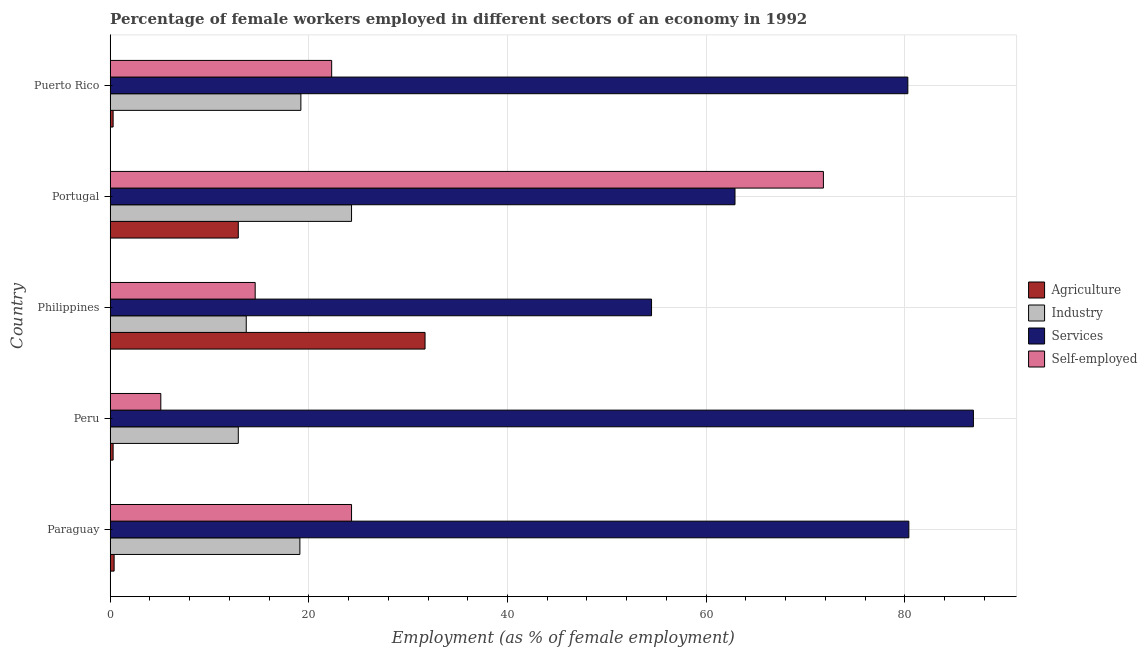How many groups of bars are there?
Ensure brevity in your answer.  5. How many bars are there on the 1st tick from the top?
Offer a very short reply. 4. What is the label of the 2nd group of bars from the top?
Keep it short and to the point. Portugal. In how many cases, is the number of bars for a given country not equal to the number of legend labels?
Offer a very short reply. 0. What is the percentage of self employed female workers in Portugal?
Ensure brevity in your answer.  71.8. Across all countries, what is the maximum percentage of female workers in industry?
Your answer should be compact. 24.3. Across all countries, what is the minimum percentage of female workers in services?
Ensure brevity in your answer.  54.5. In which country was the percentage of female workers in agriculture maximum?
Give a very brief answer. Philippines. What is the total percentage of female workers in industry in the graph?
Offer a terse response. 89.2. What is the difference between the percentage of self employed female workers in Peru and that in Portugal?
Keep it short and to the point. -66.7. What is the difference between the percentage of self employed female workers in Peru and the percentage of female workers in industry in Portugal?
Your response must be concise. -19.2. What is the average percentage of self employed female workers per country?
Your answer should be compact. 27.62. What is the difference between the percentage of female workers in agriculture and percentage of female workers in industry in Puerto Rico?
Your answer should be compact. -18.9. In how many countries, is the percentage of female workers in industry greater than 84 %?
Give a very brief answer. 0. What is the ratio of the percentage of self employed female workers in Philippines to that in Portugal?
Give a very brief answer. 0.2. What is the difference between the highest and the second highest percentage of female workers in agriculture?
Ensure brevity in your answer.  18.8. What is the difference between the highest and the lowest percentage of female workers in services?
Provide a succinct answer. 32.4. In how many countries, is the percentage of self employed female workers greater than the average percentage of self employed female workers taken over all countries?
Offer a very short reply. 1. Is the sum of the percentage of female workers in services in Peru and Puerto Rico greater than the maximum percentage of female workers in agriculture across all countries?
Offer a terse response. Yes. Is it the case that in every country, the sum of the percentage of female workers in services and percentage of female workers in industry is greater than the sum of percentage of female workers in agriculture and percentage of self employed female workers?
Your response must be concise. No. What does the 3rd bar from the top in Peru represents?
Offer a terse response. Industry. What does the 2nd bar from the bottom in Paraguay represents?
Give a very brief answer. Industry. How many countries are there in the graph?
Ensure brevity in your answer.  5. Does the graph contain grids?
Provide a succinct answer. Yes. Where does the legend appear in the graph?
Your answer should be very brief. Center right. How many legend labels are there?
Your response must be concise. 4. How are the legend labels stacked?
Make the answer very short. Vertical. What is the title of the graph?
Ensure brevity in your answer.  Percentage of female workers employed in different sectors of an economy in 1992. What is the label or title of the X-axis?
Offer a terse response. Employment (as % of female employment). What is the Employment (as % of female employment) in Agriculture in Paraguay?
Your answer should be compact. 0.4. What is the Employment (as % of female employment) of Industry in Paraguay?
Provide a short and direct response. 19.1. What is the Employment (as % of female employment) of Services in Paraguay?
Your answer should be very brief. 80.4. What is the Employment (as % of female employment) in Self-employed in Paraguay?
Your answer should be compact. 24.3. What is the Employment (as % of female employment) of Agriculture in Peru?
Ensure brevity in your answer.  0.3. What is the Employment (as % of female employment) of Industry in Peru?
Ensure brevity in your answer.  12.9. What is the Employment (as % of female employment) in Services in Peru?
Your answer should be compact. 86.9. What is the Employment (as % of female employment) in Self-employed in Peru?
Your answer should be compact. 5.1. What is the Employment (as % of female employment) in Agriculture in Philippines?
Offer a terse response. 31.7. What is the Employment (as % of female employment) of Industry in Philippines?
Keep it short and to the point. 13.7. What is the Employment (as % of female employment) in Services in Philippines?
Provide a short and direct response. 54.5. What is the Employment (as % of female employment) of Self-employed in Philippines?
Provide a succinct answer. 14.6. What is the Employment (as % of female employment) of Agriculture in Portugal?
Offer a very short reply. 12.9. What is the Employment (as % of female employment) in Industry in Portugal?
Your answer should be compact. 24.3. What is the Employment (as % of female employment) of Services in Portugal?
Your answer should be compact. 62.9. What is the Employment (as % of female employment) in Self-employed in Portugal?
Your answer should be very brief. 71.8. What is the Employment (as % of female employment) of Agriculture in Puerto Rico?
Your answer should be compact. 0.3. What is the Employment (as % of female employment) of Industry in Puerto Rico?
Your answer should be very brief. 19.2. What is the Employment (as % of female employment) of Services in Puerto Rico?
Provide a succinct answer. 80.3. What is the Employment (as % of female employment) of Self-employed in Puerto Rico?
Your answer should be very brief. 22.3. Across all countries, what is the maximum Employment (as % of female employment) of Agriculture?
Provide a succinct answer. 31.7. Across all countries, what is the maximum Employment (as % of female employment) of Industry?
Provide a short and direct response. 24.3. Across all countries, what is the maximum Employment (as % of female employment) in Services?
Your answer should be very brief. 86.9. Across all countries, what is the maximum Employment (as % of female employment) in Self-employed?
Provide a succinct answer. 71.8. Across all countries, what is the minimum Employment (as % of female employment) of Agriculture?
Make the answer very short. 0.3. Across all countries, what is the minimum Employment (as % of female employment) in Industry?
Ensure brevity in your answer.  12.9. Across all countries, what is the minimum Employment (as % of female employment) in Services?
Your response must be concise. 54.5. Across all countries, what is the minimum Employment (as % of female employment) in Self-employed?
Ensure brevity in your answer.  5.1. What is the total Employment (as % of female employment) of Agriculture in the graph?
Provide a succinct answer. 45.6. What is the total Employment (as % of female employment) of Industry in the graph?
Ensure brevity in your answer.  89.2. What is the total Employment (as % of female employment) in Services in the graph?
Ensure brevity in your answer.  365. What is the total Employment (as % of female employment) of Self-employed in the graph?
Give a very brief answer. 138.1. What is the difference between the Employment (as % of female employment) in Agriculture in Paraguay and that in Peru?
Make the answer very short. 0.1. What is the difference between the Employment (as % of female employment) of Industry in Paraguay and that in Peru?
Offer a very short reply. 6.2. What is the difference between the Employment (as % of female employment) of Agriculture in Paraguay and that in Philippines?
Offer a terse response. -31.3. What is the difference between the Employment (as % of female employment) of Industry in Paraguay and that in Philippines?
Your answer should be very brief. 5.4. What is the difference between the Employment (as % of female employment) in Services in Paraguay and that in Philippines?
Provide a succinct answer. 25.9. What is the difference between the Employment (as % of female employment) in Self-employed in Paraguay and that in Philippines?
Keep it short and to the point. 9.7. What is the difference between the Employment (as % of female employment) of Services in Paraguay and that in Portugal?
Keep it short and to the point. 17.5. What is the difference between the Employment (as % of female employment) in Self-employed in Paraguay and that in Portugal?
Provide a short and direct response. -47.5. What is the difference between the Employment (as % of female employment) in Self-employed in Paraguay and that in Puerto Rico?
Keep it short and to the point. 2. What is the difference between the Employment (as % of female employment) of Agriculture in Peru and that in Philippines?
Make the answer very short. -31.4. What is the difference between the Employment (as % of female employment) in Services in Peru and that in Philippines?
Offer a terse response. 32.4. What is the difference between the Employment (as % of female employment) in Agriculture in Peru and that in Portugal?
Your answer should be compact. -12.6. What is the difference between the Employment (as % of female employment) of Industry in Peru and that in Portugal?
Offer a very short reply. -11.4. What is the difference between the Employment (as % of female employment) in Self-employed in Peru and that in Portugal?
Keep it short and to the point. -66.7. What is the difference between the Employment (as % of female employment) in Industry in Peru and that in Puerto Rico?
Provide a short and direct response. -6.3. What is the difference between the Employment (as % of female employment) of Services in Peru and that in Puerto Rico?
Offer a terse response. 6.6. What is the difference between the Employment (as % of female employment) of Self-employed in Peru and that in Puerto Rico?
Ensure brevity in your answer.  -17.2. What is the difference between the Employment (as % of female employment) of Agriculture in Philippines and that in Portugal?
Your answer should be compact. 18.8. What is the difference between the Employment (as % of female employment) in Services in Philippines and that in Portugal?
Make the answer very short. -8.4. What is the difference between the Employment (as % of female employment) of Self-employed in Philippines and that in Portugal?
Your response must be concise. -57.2. What is the difference between the Employment (as % of female employment) of Agriculture in Philippines and that in Puerto Rico?
Provide a succinct answer. 31.4. What is the difference between the Employment (as % of female employment) of Services in Philippines and that in Puerto Rico?
Make the answer very short. -25.8. What is the difference between the Employment (as % of female employment) in Self-employed in Philippines and that in Puerto Rico?
Provide a succinct answer. -7.7. What is the difference between the Employment (as % of female employment) in Agriculture in Portugal and that in Puerto Rico?
Provide a succinct answer. 12.6. What is the difference between the Employment (as % of female employment) of Services in Portugal and that in Puerto Rico?
Make the answer very short. -17.4. What is the difference between the Employment (as % of female employment) in Self-employed in Portugal and that in Puerto Rico?
Offer a terse response. 49.5. What is the difference between the Employment (as % of female employment) of Agriculture in Paraguay and the Employment (as % of female employment) of Services in Peru?
Your answer should be compact. -86.5. What is the difference between the Employment (as % of female employment) of Agriculture in Paraguay and the Employment (as % of female employment) of Self-employed in Peru?
Offer a terse response. -4.7. What is the difference between the Employment (as % of female employment) of Industry in Paraguay and the Employment (as % of female employment) of Services in Peru?
Provide a short and direct response. -67.8. What is the difference between the Employment (as % of female employment) in Industry in Paraguay and the Employment (as % of female employment) in Self-employed in Peru?
Offer a very short reply. 14. What is the difference between the Employment (as % of female employment) in Services in Paraguay and the Employment (as % of female employment) in Self-employed in Peru?
Offer a terse response. 75.3. What is the difference between the Employment (as % of female employment) in Agriculture in Paraguay and the Employment (as % of female employment) in Services in Philippines?
Offer a terse response. -54.1. What is the difference between the Employment (as % of female employment) in Agriculture in Paraguay and the Employment (as % of female employment) in Self-employed in Philippines?
Keep it short and to the point. -14.2. What is the difference between the Employment (as % of female employment) in Industry in Paraguay and the Employment (as % of female employment) in Services in Philippines?
Give a very brief answer. -35.4. What is the difference between the Employment (as % of female employment) of Industry in Paraguay and the Employment (as % of female employment) of Self-employed in Philippines?
Provide a short and direct response. 4.5. What is the difference between the Employment (as % of female employment) in Services in Paraguay and the Employment (as % of female employment) in Self-employed in Philippines?
Offer a terse response. 65.8. What is the difference between the Employment (as % of female employment) of Agriculture in Paraguay and the Employment (as % of female employment) of Industry in Portugal?
Your response must be concise. -23.9. What is the difference between the Employment (as % of female employment) of Agriculture in Paraguay and the Employment (as % of female employment) of Services in Portugal?
Ensure brevity in your answer.  -62.5. What is the difference between the Employment (as % of female employment) of Agriculture in Paraguay and the Employment (as % of female employment) of Self-employed in Portugal?
Provide a succinct answer. -71.4. What is the difference between the Employment (as % of female employment) of Industry in Paraguay and the Employment (as % of female employment) of Services in Portugal?
Make the answer very short. -43.8. What is the difference between the Employment (as % of female employment) in Industry in Paraguay and the Employment (as % of female employment) in Self-employed in Portugal?
Your answer should be compact. -52.7. What is the difference between the Employment (as % of female employment) of Services in Paraguay and the Employment (as % of female employment) of Self-employed in Portugal?
Offer a terse response. 8.6. What is the difference between the Employment (as % of female employment) of Agriculture in Paraguay and the Employment (as % of female employment) of Industry in Puerto Rico?
Offer a terse response. -18.8. What is the difference between the Employment (as % of female employment) of Agriculture in Paraguay and the Employment (as % of female employment) of Services in Puerto Rico?
Make the answer very short. -79.9. What is the difference between the Employment (as % of female employment) in Agriculture in Paraguay and the Employment (as % of female employment) in Self-employed in Puerto Rico?
Provide a succinct answer. -21.9. What is the difference between the Employment (as % of female employment) in Industry in Paraguay and the Employment (as % of female employment) in Services in Puerto Rico?
Ensure brevity in your answer.  -61.2. What is the difference between the Employment (as % of female employment) of Services in Paraguay and the Employment (as % of female employment) of Self-employed in Puerto Rico?
Give a very brief answer. 58.1. What is the difference between the Employment (as % of female employment) of Agriculture in Peru and the Employment (as % of female employment) of Services in Philippines?
Make the answer very short. -54.2. What is the difference between the Employment (as % of female employment) of Agriculture in Peru and the Employment (as % of female employment) of Self-employed in Philippines?
Your answer should be compact. -14.3. What is the difference between the Employment (as % of female employment) in Industry in Peru and the Employment (as % of female employment) in Services in Philippines?
Provide a short and direct response. -41.6. What is the difference between the Employment (as % of female employment) of Industry in Peru and the Employment (as % of female employment) of Self-employed in Philippines?
Offer a very short reply. -1.7. What is the difference between the Employment (as % of female employment) of Services in Peru and the Employment (as % of female employment) of Self-employed in Philippines?
Offer a very short reply. 72.3. What is the difference between the Employment (as % of female employment) of Agriculture in Peru and the Employment (as % of female employment) of Services in Portugal?
Provide a short and direct response. -62.6. What is the difference between the Employment (as % of female employment) of Agriculture in Peru and the Employment (as % of female employment) of Self-employed in Portugal?
Give a very brief answer. -71.5. What is the difference between the Employment (as % of female employment) in Industry in Peru and the Employment (as % of female employment) in Self-employed in Portugal?
Make the answer very short. -58.9. What is the difference between the Employment (as % of female employment) of Services in Peru and the Employment (as % of female employment) of Self-employed in Portugal?
Keep it short and to the point. 15.1. What is the difference between the Employment (as % of female employment) of Agriculture in Peru and the Employment (as % of female employment) of Industry in Puerto Rico?
Your answer should be compact. -18.9. What is the difference between the Employment (as % of female employment) in Agriculture in Peru and the Employment (as % of female employment) in Services in Puerto Rico?
Give a very brief answer. -80. What is the difference between the Employment (as % of female employment) of Agriculture in Peru and the Employment (as % of female employment) of Self-employed in Puerto Rico?
Offer a very short reply. -22. What is the difference between the Employment (as % of female employment) of Industry in Peru and the Employment (as % of female employment) of Services in Puerto Rico?
Your response must be concise. -67.4. What is the difference between the Employment (as % of female employment) of Industry in Peru and the Employment (as % of female employment) of Self-employed in Puerto Rico?
Offer a very short reply. -9.4. What is the difference between the Employment (as % of female employment) in Services in Peru and the Employment (as % of female employment) in Self-employed in Puerto Rico?
Your answer should be compact. 64.6. What is the difference between the Employment (as % of female employment) in Agriculture in Philippines and the Employment (as % of female employment) in Services in Portugal?
Your response must be concise. -31.2. What is the difference between the Employment (as % of female employment) in Agriculture in Philippines and the Employment (as % of female employment) in Self-employed in Portugal?
Your answer should be compact. -40.1. What is the difference between the Employment (as % of female employment) of Industry in Philippines and the Employment (as % of female employment) of Services in Portugal?
Offer a very short reply. -49.2. What is the difference between the Employment (as % of female employment) in Industry in Philippines and the Employment (as % of female employment) in Self-employed in Portugal?
Offer a terse response. -58.1. What is the difference between the Employment (as % of female employment) in Services in Philippines and the Employment (as % of female employment) in Self-employed in Portugal?
Keep it short and to the point. -17.3. What is the difference between the Employment (as % of female employment) of Agriculture in Philippines and the Employment (as % of female employment) of Industry in Puerto Rico?
Make the answer very short. 12.5. What is the difference between the Employment (as % of female employment) of Agriculture in Philippines and the Employment (as % of female employment) of Services in Puerto Rico?
Provide a short and direct response. -48.6. What is the difference between the Employment (as % of female employment) of Agriculture in Philippines and the Employment (as % of female employment) of Self-employed in Puerto Rico?
Your answer should be very brief. 9.4. What is the difference between the Employment (as % of female employment) in Industry in Philippines and the Employment (as % of female employment) in Services in Puerto Rico?
Offer a terse response. -66.6. What is the difference between the Employment (as % of female employment) in Industry in Philippines and the Employment (as % of female employment) in Self-employed in Puerto Rico?
Make the answer very short. -8.6. What is the difference between the Employment (as % of female employment) of Services in Philippines and the Employment (as % of female employment) of Self-employed in Puerto Rico?
Offer a terse response. 32.2. What is the difference between the Employment (as % of female employment) of Agriculture in Portugal and the Employment (as % of female employment) of Industry in Puerto Rico?
Provide a succinct answer. -6.3. What is the difference between the Employment (as % of female employment) of Agriculture in Portugal and the Employment (as % of female employment) of Services in Puerto Rico?
Provide a short and direct response. -67.4. What is the difference between the Employment (as % of female employment) in Industry in Portugal and the Employment (as % of female employment) in Services in Puerto Rico?
Your answer should be very brief. -56. What is the difference between the Employment (as % of female employment) in Industry in Portugal and the Employment (as % of female employment) in Self-employed in Puerto Rico?
Make the answer very short. 2. What is the difference between the Employment (as % of female employment) in Services in Portugal and the Employment (as % of female employment) in Self-employed in Puerto Rico?
Your response must be concise. 40.6. What is the average Employment (as % of female employment) in Agriculture per country?
Your response must be concise. 9.12. What is the average Employment (as % of female employment) of Industry per country?
Your answer should be very brief. 17.84. What is the average Employment (as % of female employment) in Self-employed per country?
Provide a short and direct response. 27.62. What is the difference between the Employment (as % of female employment) in Agriculture and Employment (as % of female employment) in Industry in Paraguay?
Ensure brevity in your answer.  -18.7. What is the difference between the Employment (as % of female employment) of Agriculture and Employment (as % of female employment) of Services in Paraguay?
Provide a short and direct response. -80. What is the difference between the Employment (as % of female employment) in Agriculture and Employment (as % of female employment) in Self-employed in Paraguay?
Offer a terse response. -23.9. What is the difference between the Employment (as % of female employment) in Industry and Employment (as % of female employment) in Services in Paraguay?
Offer a terse response. -61.3. What is the difference between the Employment (as % of female employment) of Industry and Employment (as % of female employment) of Self-employed in Paraguay?
Keep it short and to the point. -5.2. What is the difference between the Employment (as % of female employment) of Services and Employment (as % of female employment) of Self-employed in Paraguay?
Provide a short and direct response. 56.1. What is the difference between the Employment (as % of female employment) in Agriculture and Employment (as % of female employment) in Industry in Peru?
Provide a short and direct response. -12.6. What is the difference between the Employment (as % of female employment) of Agriculture and Employment (as % of female employment) of Services in Peru?
Your answer should be very brief. -86.6. What is the difference between the Employment (as % of female employment) in Agriculture and Employment (as % of female employment) in Self-employed in Peru?
Your answer should be very brief. -4.8. What is the difference between the Employment (as % of female employment) in Industry and Employment (as % of female employment) in Services in Peru?
Provide a succinct answer. -74. What is the difference between the Employment (as % of female employment) of Industry and Employment (as % of female employment) of Self-employed in Peru?
Provide a short and direct response. 7.8. What is the difference between the Employment (as % of female employment) in Services and Employment (as % of female employment) in Self-employed in Peru?
Your response must be concise. 81.8. What is the difference between the Employment (as % of female employment) of Agriculture and Employment (as % of female employment) of Services in Philippines?
Offer a very short reply. -22.8. What is the difference between the Employment (as % of female employment) of Agriculture and Employment (as % of female employment) of Self-employed in Philippines?
Offer a very short reply. 17.1. What is the difference between the Employment (as % of female employment) in Industry and Employment (as % of female employment) in Services in Philippines?
Your answer should be very brief. -40.8. What is the difference between the Employment (as % of female employment) of Industry and Employment (as % of female employment) of Self-employed in Philippines?
Ensure brevity in your answer.  -0.9. What is the difference between the Employment (as % of female employment) of Services and Employment (as % of female employment) of Self-employed in Philippines?
Make the answer very short. 39.9. What is the difference between the Employment (as % of female employment) of Agriculture and Employment (as % of female employment) of Services in Portugal?
Offer a terse response. -50. What is the difference between the Employment (as % of female employment) of Agriculture and Employment (as % of female employment) of Self-employed in Portugal?
Your answer should be very brief. -58.9. What is the difference between the Employment (as % of female employment) of Industry and Employment (as % of female employment) of Services in Portugal?
Provide a succinct answer. -38.6. What is the difference between the Employment (as % of female employment) of Industry and Employment (as % of female employment) of Self-employed in Portugal?
Your answer should be very brief. -47.5. What is the difference between the Employment (as % of female employment) of Agriculture and Employment (as % of female employment) of Industry in Puerto Rico?
Your answer should be compact. -18.9. What is the difference between the Employment (as % of female employment) of Agriculture and Employment (as % of female employment) of Services in Puerto Rico?
Your answer should be very brief. -80. What is the difference between the Employment (as % of female employment) of Industry and Employment (as % of female employment) of Services in Puerto Rico?
Offer a terse response. -61.1. What is the difference between the Employment (as % of female employment) of Industry and Employment (as % of female employment) of Self-employed in Puerto Rico?
Provide a short and direct response. -3.1. What is the difference between the Employment (as % of female employment) of Services and Employment (as % of female employment) of Self-employed in Puerto Rico?
Provide a short and direct response. 58. What is the ratio of the Employment (as % of female employment) in Agriculture in Paraguay to that in Peru?
Your answer should be compact. 1.33. What is the ratio of the Employment (as % of female employment) of Industry in Paraguay to that in Peru?
Your answer should be compact. 1.48. What is the ratio of the Employment (as % of female employment) in Services in Paraguay to that in Peru?
Ensure brevity in your answer.  0.93. What is the ratio of the Employment (as % of female employment) of Self-employed in Paraguay to that in Peru?
Give a very brief answer. 4.76. What is the ratio of the Employment (as % of female employment) in Agriculture in Paraguay to that in Philippines?
Ensure brevity in your answer.  0.01. What is the ratio of the Employment (as % of female employment) in Industry in Paraguay to that in Philippines?
Keep it short and to the point. 1.39. What is the ratio of the Employment (as % of female employment) of Services in Paraguay to that in Philippines?
Your response must be concise. 1.48. What is the ratio of the Employment (as % of female employment) of Self-employed in Paraguay to that in Philippines?
Keep it short and to the point. 1.66. What is the ratio of the Employment (as % of female employment) of Agriculture in Paraguay to that in Portugal?
Give a very brief answer. 0.03. What is the ratio of the Employment (as % of female employment) of Industry in Paraguay to that in Portugal?
Provide a short and direct response. 0.79. What is the ratio of the Employment (as % of female employment) in Services in Paraguay to that in Portugal?
Your answer should be very brief. 1.28. What is the ratio of the Employment (as % of female employment) of Self-employed in Paraguay to that in Portugal?
Make the answer very short. 0.34. What is the ratio of the Employment (as % of female employment) of Self-employed in Paraguay to that in Puerto Rico?
Keep it short and to the point. 1.09. What is the ratio of the Employment (as % of female employment) of Agriculture in Peru to that in Philippines?
Ensure brevity in your answer.  0.01. What is the ratio of the Employment (as % of female employment) of Industry in Peru to that in Philippines?
Offer a very short reply. 0.94. What is the ratio of the Employment (as % of female employment) of Services in Peru to that in Philippines?
Give a very brief answer. 1.59. What is the ratio of the Employment (as % of female employment) in Self-employed in Peru to that in Philippines?
Your response must be concise. 0.35. What is the ratio of the Employment (as % of female employment) in Agriculture in Peru to that in Portugal?
Keep it short and to the point. 0.02. What is the ratio of the Employment (as % of female employment) of Industry in Peru to that in Portugal?
Keep it short and to the point. 0.53. What is the ratio of the Employment (as % of female employment) of Services in Peru to that in Portugal?
Provide a short and direct response. 1.38. What is the ratio of the Employment (as % of female employment) in Self-employed in Peru to that in Portugal?
Keep it short and to the point. 0.07. What is the ratio of the Employment (as % of female employment) of Industry in Peru to that in Puerto Rico?
Your answer should be very brief. 0.67. What is the ratio of the Employment (as % of female employment) of Services in Peru to that in Puerto Rico?
Offer a very short reply. 1.08. What is the ratio of the Employment (as % of female employment) of Self-employed in Peru to that in Puerto Rico?
Offer a terse response. 0.23. What is the ratio of the Employment (as % of female employment) of Agriculture in Philippines to that in Portugal?
Ensure brevity in your answer.  2.46. What is the ratio of the Employment (as % of female employment) in Industry in Philippines to that in Portugal?
Keep it short and to the point. 0.56. What is the ratio of the Employment (as % of female employment) of Services in Philippines to that in Portugal?
Keep it short and to the point. 0.87. What is the ratio of the Employment (as % of female employment) of Self-employed in Philippines to that in Portugal?
Offer a very short reply. 0.2. What is the ratio of the Employment (as % of female employment) in Agriculture in Philippines to that in Puerto Rico?
Make the answer very short. 105.67. What is the ratio of the Employment (as % of female employment) in Industry in Philippines to that in Puerto Rico?
Give a very brief answer. 0.71. What is the ratio of the Employment (as % of female employment) of Services in Philippines to that in Puerto Rico?
Your answer should be very brief. 0.68. What is the ratio of the Employment (as % of female employment) of Self-employed in Philippines to that in Puerto Rico?
Provide a short and direct response. 0.65. What is the ratio of the Employment (as % of female employment) of Industry in Portugal to that in Puerto Rico?
Your answer should be very brief. 1.27. What is the ratio of the Employment (as % of female employment) in Services in Portugal to that in Puerto Rico?
Offer a terse response. 0.78. What is the ratio of the Employment (as % of female employment) in Self-employed in Portugal to that in Puerto Rico?
Provide a short and direct response. 3.22. What is the difference between the highest and the second highest Employment (as % of female employment) in Industry?
Give a very brief answer. 5.1. What is the difference between the highest and the second highest Employment (as % of female employment) in Self-employed?
Ensure brevity in your answer.  47.5. What is the difference between the highest and the lowest Employment (as % of female employment) in Agriculture?
Provide a short and direct response. 31.4. What is the difference between the highest and the lowest Employment (as % of female employment) of Services?
Offer a terse response. 32.4. What is the difference between the highest and the lowest Employment (as % of female employment) of Self-employed?
Give a very brief answer. 66.7. 